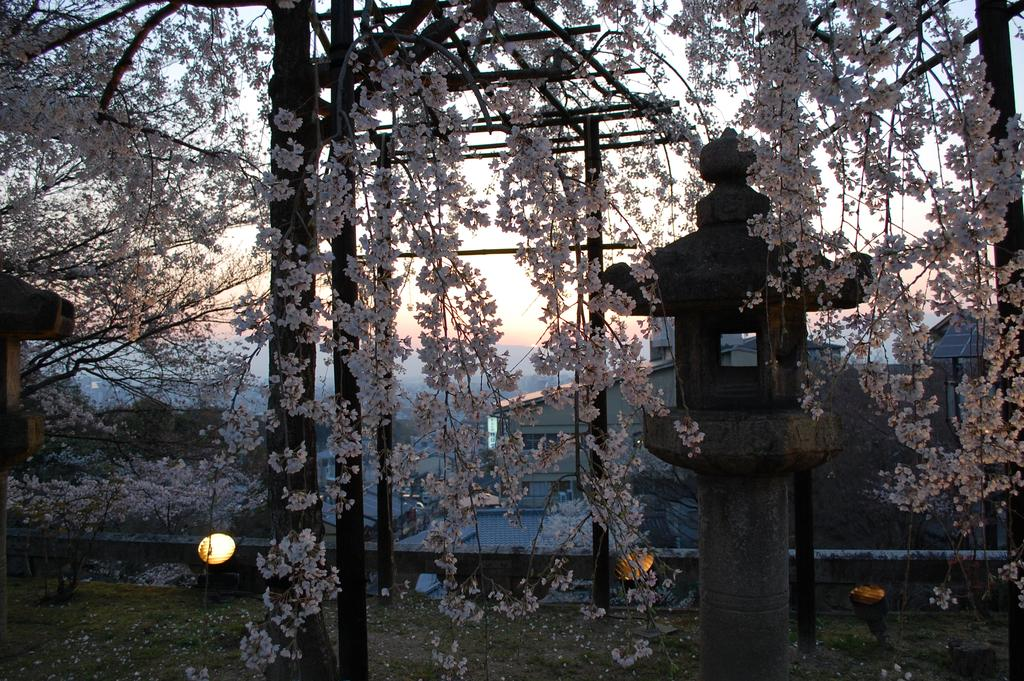What type of natural elements can be seen in the image? There are trees in the image. What type of man-made structures are present in the image? There are buildings in the image. What other objects can be seen in the image besides trees and buildings? There are other objects in the image. What can be seen in the distance in the image? The sky is visible in the background of the image. How many sisters are present in the image? There are no sisters depicted in the image. What color are the toes of the person in the image? There is no person present in the image, so there are no toes to describe. 